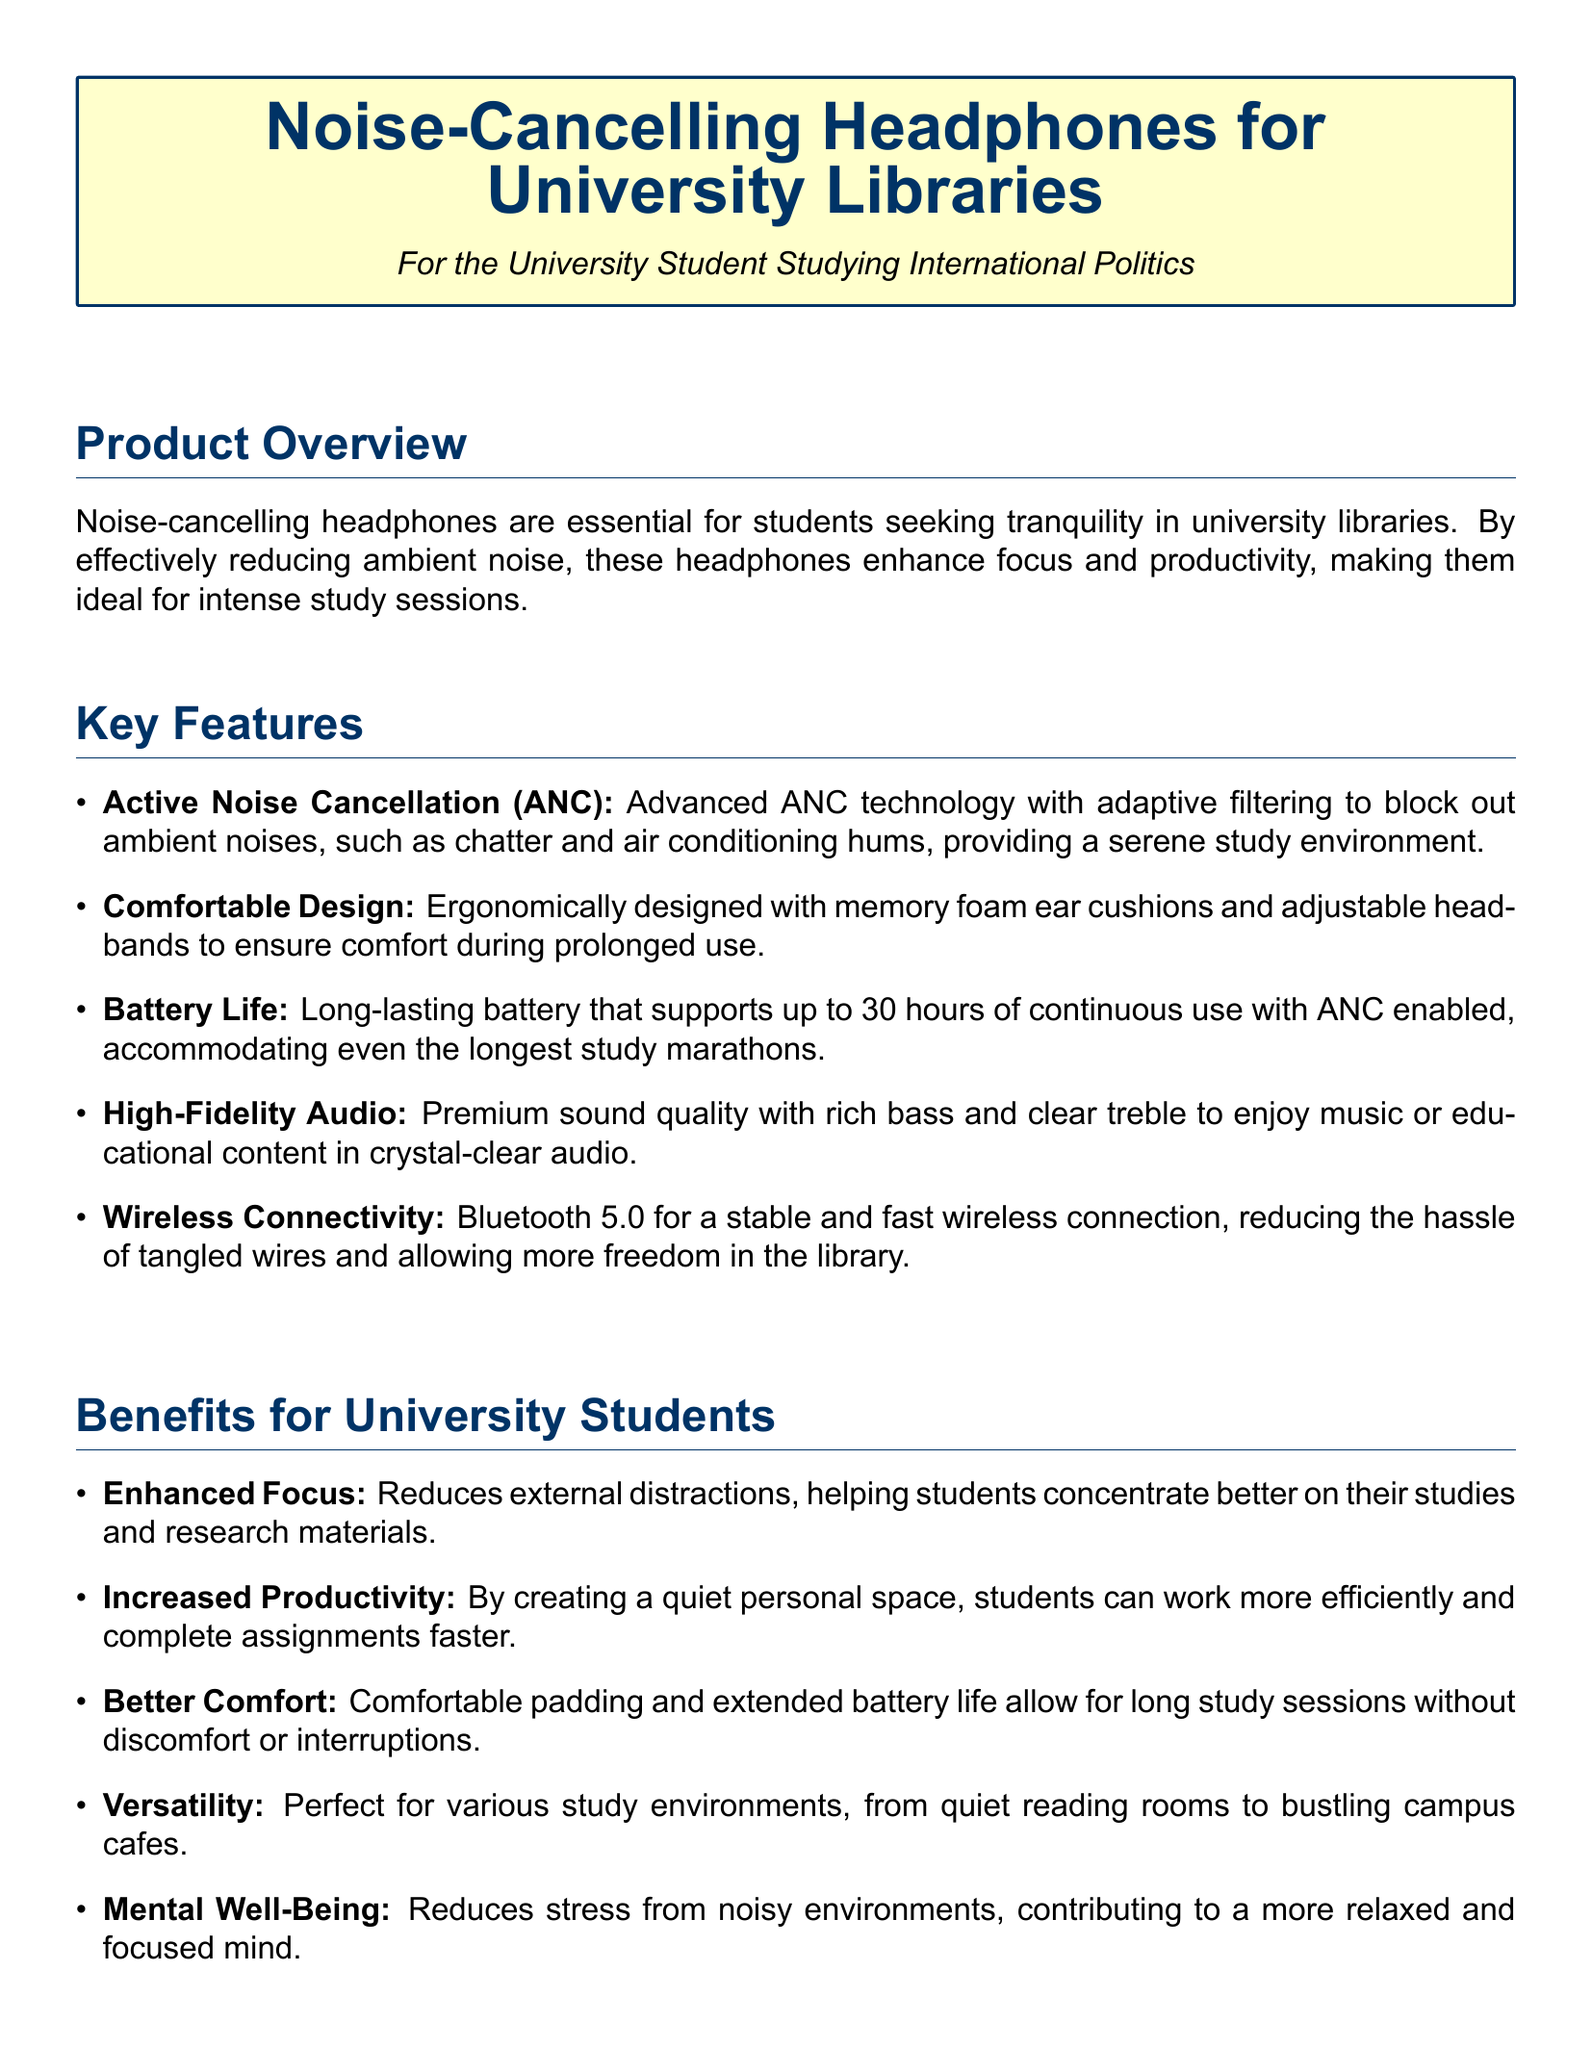What is the main purpose of noise-cancelling headphones for university students? The main purpose is to enhance focus and productivity by reducing ambient noise in university libraries.
Answer: Enhance focus and productivity What technology is used in these headphones to reduce noise? They utilize Advanced Noise Cancellation (ANC) technology with adaptive filtering to block out ambient noises.
Answer: Active Noise Cancellation (ANC) How long is the battery life of the headphones with ANC enabled? The battery life supports up to 30 hours of continuous use with ANC enabled.
Answer: 30 hours What is a key design feature of the headphones for comfort? They are ergonomically designed with memory foam ear cushions and adjustable headbands.
Answer: Memory foam ear cushions Name one benefit of using noise-cancelling headphones while studying. One benefit is the reduction of external distractions, which helps students concentrate better.
Answer: Enhanced Focus Which headphone model is renowned for its superior noise cancellation? The Bose QuietComfort 35 II is renowned for its superior noise cancellation.
Answer: Bose QuietComfort 35 II What aspect of the headphones might contribute to mental well-being? The headphones reduce stress from noisy environments, contributing to a more relaxed mind.
Answer: Reduces stress List one product example mentioned in the document. Sony WH-1000XM4 is one of the product examples mentioned.
Answer: Sony WH-1000XM4 What feature enhances connectivity in the headphones? Bluetooth 5.0 provides stable and fast wireless connections.
Answer: Bluetooth 5.0 